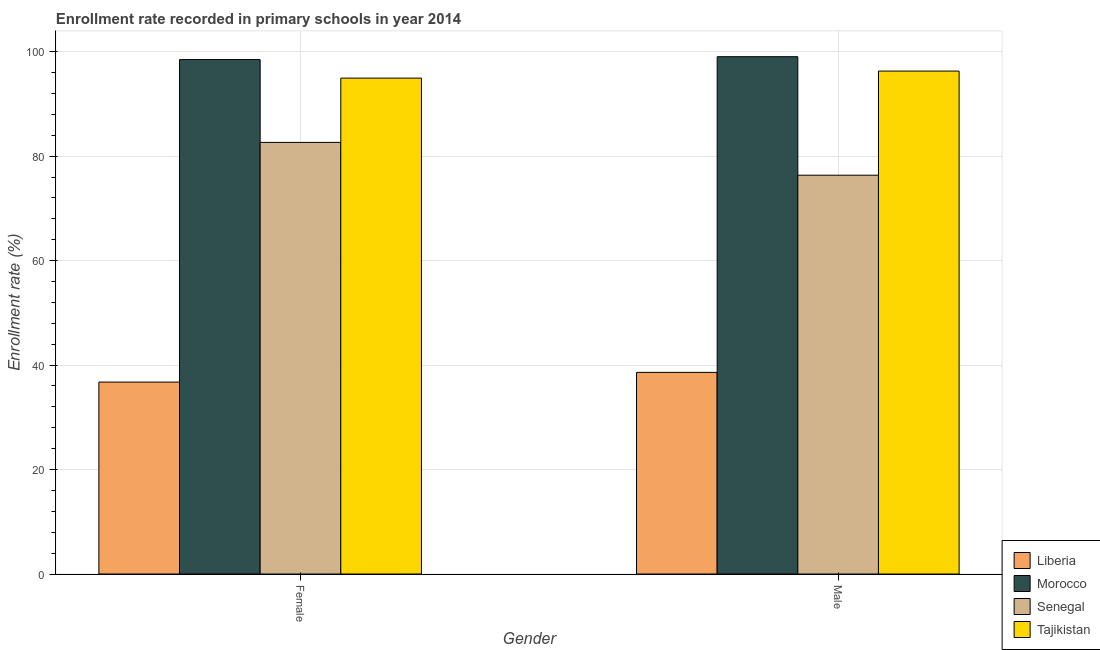How many bars are there on the 1st tick from the left?
Make the answer very short. 4. How many bars are there on the 2nd tick from the right?
Provide a short and direct response. 4. What is the enrollment rate of male students in Morocco?
Make the answer very short. 99.03. Across all countries, what is the maximum enrollment rate of male students?
Your answer should be very brief. 99.03. Across all countries, what is the minimum enrollment rate of male students?
Offer a terse response. 38.6. In which country was the enrollment rate of male students maximum?
Your answer should be very brief. Morocco. In which country was the enrollment rate of female students minimum?
Keep it short and to the point. Liberia. What is the total enrollment rate of female students in the graph?
Make the answer very short. 312.78. What is the difference between the enrollment rate of female students in Liberia and that in Tajikistan?
Keep it short and to the point. -58.19. What is the difference between the enrollment rate of male students in Liberia and the enrollment rate of female students in Tajikistan?
Your answer should be very brief. -56.33. What is the average enrollment rate of female students per country?
Offer a very short reply. 78.2. What is the difference between the enrollment rate of male students and enrollment rate of female students in Tajikistan?
Provide a succinct answer. 1.35. What is the ratio of the enrollment rate of female students in Senegal to that in Tajikistan?
Offer a very short reply. 0.87. What does the 3rd bar from the left in Male represents?
Offer a terse response. Senegal. What does the 3rd bar from the right in Male represents?
Your response must be concise. Morocco. How many bars are there?
Provide a succinct answer. 8. How many countries are there in the graph?
Ensure brevity in your answer.  4. Does the graph contain grids?
Keep it short and to the point. Yes. Where does the legend appear in the graph?
Provide a succinct answer. Bottom right. How are the legend labels stacked?
Provide a short and direct response. Vertical. What is the title of the graph?
Your answer should be compact. Enrollment rate recorded in primary schools in year 2014. Does "Philippines" appear as one of the legend labels in the graph?
Provide a succinct answer. No. What is the label or title of the X-axis?
Provide a short and direct response. Gender. What is the label or title of the Y-axis?
Provide a succinct answer. Enrollment rate (%). What is the Enrollment rate (%) of Liberia in Female?
Keep it short and to the point. 36.74. What is the Enrollment rate (%) in Morocco in Female?
Make the answer very short. 98.48. What is the Enrollment rate (%) of Senegal in Female?
Offer a very short reply. 82.63. What is the Enrollment rate (%) in Tajikistan in Female?
Your answer should be very brief. 94.93. What is the Enrollment rate (%) of Liberia in Male?
Ensure brevity in your answer.  38.6. What is the Enrollment rate (%) of Morocco in Male?
Offer a very short reply. 99.03. What is the Enrollment rate (%) in Senegal in Male?
Provide a succinct answer. 76.34. What is the Enrollment rate (%) of Tajikistan in Male?
Your response must be concise. 96.28. Across all Gender, what is the maximum Enrollment rate (%) in Liberia?
Keep it short and to the point. 38.6. Across all Gender, what is the maximum Enrollment rate (%) in Morocco?
Ensure brevity in your answer.  99.03. Across all Gender, what is the maximum Enrollment rate (%) in Senegal?
Give a very brief answer. 82.63. Across all Gender, what is the maximum Enrollment rate (%) in Tajikistan?
Provide a succinct answer. 96.28. Across all Gender, what is the minimum Enrollment rate (%) in Liberia?
Ensure brevity in your answer.  36.74. Across all Gender, what is the minimum Enrollment rate (%) of Morocco?
Ensure brevity in your answer.  98.48. Across all Gender, what is the minimum Enrollment rate (%) in Senegal?
Keep it short and to the point. 76.34. Across all Gender, what is the minimum Enrollment rate (%) of Tajikistan?
Give a very brief answer. 94.93. What is the total Enrollment rate (%) in Liberia in the graph?
Your answer should be compact. 75.34. What is the total Enrollment rate (%) of Morocco in the graph?
Your response must be concise. 197.51. What is the total Enrollment rate (%) in Senegal in the graph?
Offer a very short reply. 158.97. What is the total Enrollment rate (%) of Tajikistan in the graph?
Your answer should be very brief. 191.22. What is the difference between the Enrollment rate (%) in Liberia in Female and that in Male?
Provide a succinct answer. -1.86. What is the difference between the Enrollment rate (%) of Morocco in Female and that in Male?
Make the answer very short. -0.55. What is the difference between the Enrollment rate (%) in Senegal in Female and that in Male?
Your response must be concise. 6.28. What is the difference between the Enrollment rate (%) of Tajikistan in Female and that in Male?
Provide a short and direct response. -1.35. What is the difference between the Enrollment rate (%) of Liberia in Female and the Enrollment rate (%) of Morocco in Male?
Keep it short and to the point. -62.29. What is the difference between the Enrollment rate (%) in Liberia in Female and the Enrollment rate (%) in Senegal in Male?
Your answer should be very brief. -39.6. What is the difference between the Enrollment rate (%) in Liberia in Female and the Enrollment rate (%) in Tajikistan in Male?
Make the answer very short. -59.54. What is the difference between the Enrollment rate (%) of Morocco in Female and the Enrollment rate (%) of Senegal in Male?
Offer a very short reply. 22.14. What is the difference between the Enrollment rate (%) in Morocco in Female and the Enrollment rate (%) in Tajikistan in Male?
Provide a succinct answer. 2.2. What is the difference between the Enrollment rate (%) in Senegal in Female and the Enrollment rate (%) in Tajikistan in Male?
Offer a terse response. -13.66. What is the average Enrollment rate (%) in Liberia per Gender?
Your answer should be very brief. 37.67. What is the average Enrollment rate (%) in Morocco per Gender?
Your response must be concise. 98.76. What is the average Enrollment rate (%) of Senegal per Gender?
Provide a succinct answer. 79.48. What is the average Enrollment rate (%) in Tajikistan per Gender?
Your answer should be compact. 95.61. What is the difference between the Enrollment rate (%) of Liberia and Enrollment rate (%) of Morocco in Female?
Your answer should be compact. -61.74. What is the difference between the Enrollment rate (%) in Liberia and Enrollment rate (%) in Senegal in Female?
Offer a terse response. -45.88. What is the difference between the Enrollment rate (%) in Liberia and Enrollment rate (%) in Tajikistan in Female?
Give a very brief answer. -58.19. What is the difference between the Enrollment rate (%) of Morocco and Enrollment rate (%) of Senegal in Female?
Offer a very short reply. 15.86. What is the difference between the Enrollment rate (%) of Morocco and Enrollment rate (%) of Tajikistan in Female?
Your response must be concise. 3.55. What is the difference between the Enrollment rate (%) of Senegal and Enrollment rate (%) of Tajikistan in Female?
Offer a terse response. -12.31. What is the difference between the Enrollment rate (%) of Liberia and Enrollment rate (%) of Morocco in Male?
Make the answer very short. -60.43. What is the difference between the Enrollment rate (%) in Liberia and Enrollment rate (%) in Senegal in Male?
Give a very brief answer. -37.74. What is the difference between the Enrollment rate (%) in Liberia and Enrollment rate (%) in Tajikistan in Male?
Give a very brief answer. -57.68. What is the difference between the Enrollment rate (%) of Morocco and Enrollment rate (%) of Senegal in Male?
Make the answer very short. 22.69. What is the difference between the Enrollment rate (%) of Morocco and Enrollment rate (%) of Tajikistan in Male?
Provide a succinct answer. 2.75. What is the difference between the Enrollment rate (%) of Senegal and Enrollment rate (%) of Tajikistan in Male?
Provide a succinct answer. -19.94. What is the ratio of the Enrollment rate (%) in Liberia in Female to that in Male?
Your answer should be compact. 0.95. What is the ratio of the Enrollment rate (%) in Morocco in Female to that in Male?
Offer a very short reply. 0.99. What is the ratio of the Enrollment rate (%) of Senegal in Female to that in Male?
Keep it short and to the point. 1.08. What is the ratio of the Enrollment rate (%) of Tajikistan in Female to that in Male?
Your response must be concise. 0.99. What is the difference between the highest and the second highest Enrollment rate (%) of Liberia?
Provide a succinct answer. 1.86. What is the difference between the highest and the second highest Enrollment rate (%) in Morocco?
Ensure brevity in your answer.  0.55. What is the difference between the highest and the second highest Enrollment rate (%) of Senegal?
Your answer should be compact. 6.28. What is the difference between the highest and the second highest Enrollment rate (%) of Tajikistan?
Your response must be concise. 1.35. What is the difference between the highest and the lowest Enrollment rate (%) in Liberia?
Ensure brevity in your answer.  1.86. What is the difference between the highest and the lowest Enrollment rate (%) in Morocco?
Offer a very short reply. 0.55. What is the difference between the highest and the lowest Enrollment rate (%) in Senegal?
Provide a short and direct response. 6.28. What is the difference between the highest and the lowest Enrollment rate (%) of Tajikistan?
Give a very brief answer. 1.35. 